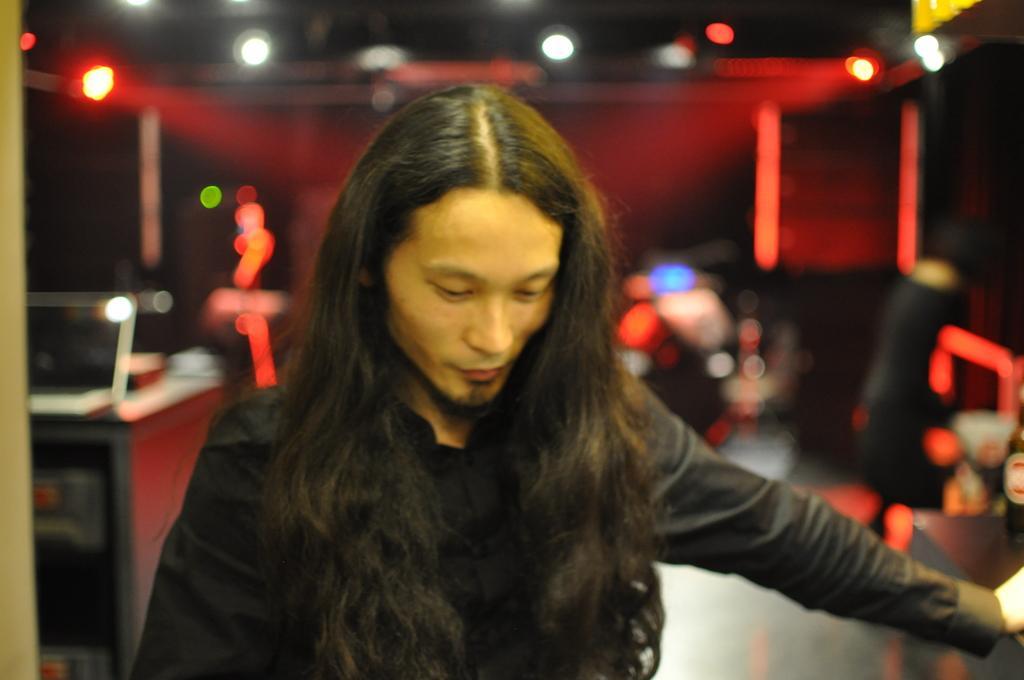Please provide a concise description of this image. In the foreground of the picture there is a person. In the background we can see lights only because it is blurred. 